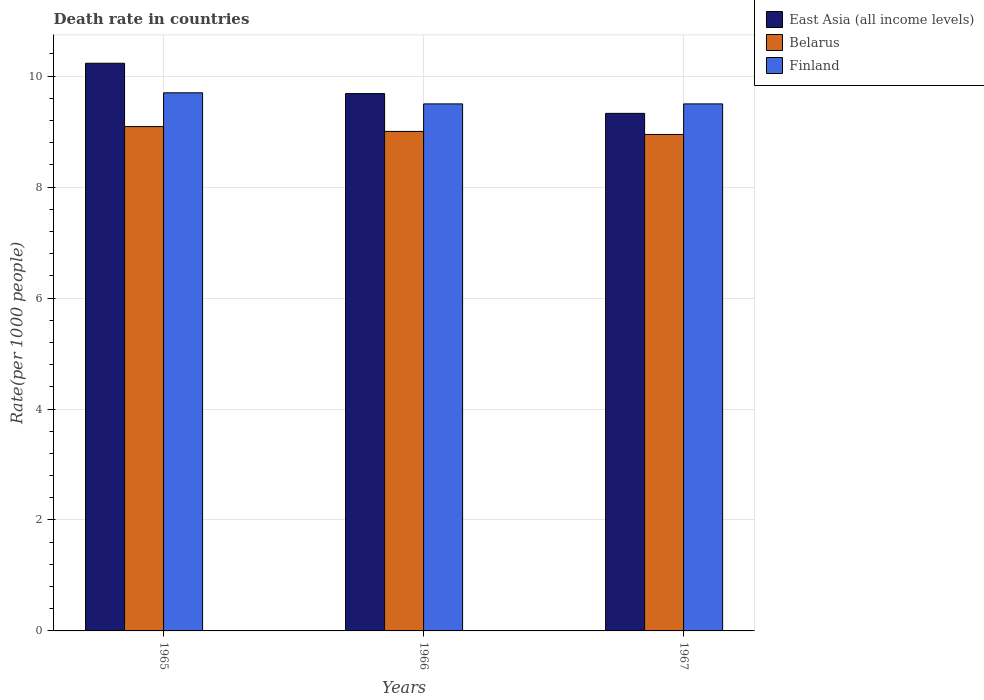How many different coloured bars are there?
Your answer should be compact. 3. How many groups of bars are there?
Keep it short and to the point. 3. Are the number of bars per tick equal to the number of legend labels?
Offer a very short reply. Yes. Are the number of bars on each tick of the X-axis equal?
Ensure brevity in your answer.  Yes. How many bars are there on the 2nd tick from the right?
Keep it short and to the point. 3. What is the label of the 3rd group of bars from the left?
Provide a short and direct response. 1967. What is the death rate in East Asia (all income levels) in 1966?
Your response must be concise. 9.69. Across all years, what is the maximum death rate in Belarus?
Keep it short and to the point. 9.09. Across all years, what is the minimum death rate in Belarus?
Ensure brevity in your answer.  8.95. In which year was the death rate in Belarus maximum?
Keep it short and to the point. 1965. In which year was the death rate in Belarus minimum?
Your answer should be compact. 1967. What is the total death rate in Belarus in the graph?
Offer a terse response. 27.04. What is the difference between the death rate in East Asia (all income levels) in 1966 and that in 1967?
Make the answer very short. 0.36. What is the difference between the death rate in Belarus in 1965 and the death rate in Finland in 1967?
Give a very brief answer. -0.41. What is the average death rate in Belarus per year?
Your response must be concise. 9.01. In the year 1965, what is the difference between the death rate in Belarus and death rate in East Asia (all income levels)?
Offer a terse response. -1.14. In how many years, is the death rate in East Asia (all income levels) greater than 2.8?
Your answer should be very brief. 3. What is the ratio of the death rate in East Asia (all income levels) in 1965 to that in 1967?
Provide a succinct answer. 1.1. Is the difference between the death rate in Belarus in 1965 and 1967 greater than the difference between the death rate in East Asia (all income levels) in 1965 and 1967?
Give a very brief answer. No. What is the difference between the highest and the second highest death rate in Finland?
Provide a succinct answer. 0.2. What is the difference between the highest and the lowest death rate in Finland?
Your response must be concise. 0.2. What does the 3rd bar from the right in 1966 represents?
Ensure brevity in your answer.  East Asia (all income levels). Is it the case that in every year, the sum of the death rate in Belarus and death rate in East Asia (all income levels) is greater than the death rate in Finland?
Offer a very short reply. Yes. How many bars are there?
Provide a succinct answer. 9. Does the graph contain any zero values?
Ensure brevity in your answer.  No. Where does the legend appear in the graph?
Ensure brevity in your answer.  Top right. How are the legend labels stacked?
Your answer should be compact. Vertical. What is the title of the graph?
Offer a very short reply. Death rate in countries. Does "South Africa" appear as one of the legend labels in the graph?
Give a very brief answer. No. What is the label or title of the Y-axis?
Ensure brevity in your answer.  Rate(per 1000 people). What is the Rate(per 1000 people) in East Asia (all income levels) in 1965?
Ensure brevity in your answer.  10.23. What is the Rate(per 1000 people) in Belarus in 1965?
Ensure brevity in your answer.  9.09. What is the Rate(per 1000 people) in East Asia (all income levels) in 1966?
Offer a terse response. 9.69. What is the Rate(per 1000 people) in Belarus in 1966?
Offer a terse response. 9. What is the Rate(per 1000 people) of East Asia (all income levels) in 1967?
Your response must be concise. 9.33. What is the Rate(per 1000 people) in Belarus in 1967?
Keep it short and to the point. 8.95. What is the Rate(per 1000 people) in Finland in 1967?
Provide a short and direct response. 9.5. Across all years, what is the maximum Rate(per 1000 people) in East Asia (all income levels)?
Provide a succinct answer. 10.23. Across all years, what is the maximum Rate(per 1000 people) in Belarus?
Give a very brief answer. 9.09. Across all years, what is the minimum Rate(per 1000 people) in East Asia (all income levels)?
Give a very brief answer. 9.33. Across all years, what is the minimum Rate(per 1000 people) of Belarus?
Your answer should be compact. 8.95. Across all years, what is the minimum Rate(per 1000 people) of Finland?
Provide a succinct answer. 9.5. What is the total Rate(per 1000 people) in East Asia (all income levels) in the graph?
Your answer should be compact. 29.25. What is the total Rate(per 1000 people) of Belarus in the graph?
Provide a short and direct response. 27.04. What is the total Rate(per 1000 people) of Finland in the graph?
Provide a succinct answer. 28.7. What is the difference between the Rate(per 1000 people) in East Asia (all income levels) in 1965 and that in 1966?
Ensure brevity in your answer.  0.55. What is the difference between the Rate(per 1000 people) of Belarus in 1965 and that in 1966?
Provide a succinct answer. 0.09. What is the difference between the Rate(per 1000 people) of East Asia (all income levels) in 1965 and that in 1967?
Provide a succinct answer. 0.9. What is the difference between the Rate(per 1000 people) in Belarus in 1965 and that in 1967?
Your answer should be compact. 0.14. What is the difference between the Rate(per 1000 people) in East Asia (all income levels) in 1966 and that in 1967?
Your answer should be very brief. 0.36. What is the difference between the Rate(per 1000 people) of Belarus in 1966 and that in 1967?
Ensure brevity in your answer.  0.06. What is the difference between the Rate(per 1000 people) in Finland in 1966 and that in 1967?
Offer a very short reply. 0. What is the difference between the Rate(per 1000 people) of East Asia (all income levels) in 1965 and the Rate(per 1000 people) of Belarus in 1966?
Your answer should be very brief. 1.23. What is the difference between the Rate(per 1000 people) of East Asia (all income levels) in 1965 and the Rate(per 1000 people) of Finland in 1966?
Your response must be concise. 0.73. What is the difference between the Rate(per 1000 people) in Belarus in 1965 and the Rate(per 1000 people) in Finland in 1966?
Provide a succinct answer. -0.41. What is the difference between the Rate(per 1000 people) of East Asia (all income levels) in 1965 and the Rate(per 1000 people) of Belarus in 1967?
Offer a terse response. 1.28. What is the difference between the Rate(per 1000 people) in East Asia (all income levels) in 1965 and the Rate(per 1000 people) in Finland in 1967?
Your answer should be very brief. 0.73. What is the difference between the Rate(per 1000 people) in Belarus in 1965 and the Rate(per 1000 people) in Finland in 1967?
Offer a very short reply. -0.41. What is the difference between the Rate(per 1000 people) of East Asia (all income levels) in 1966 and the Rate(per 1000 people) of Belarus in 1967?
Your answer should be compact. 0.74. What is the difference between the Rate(per 1000 people) in East Asia (all income levels) in 1966 and the Rate(per 1000 people) in Finland in 1967?
Give a very brief answer. 0.19. What is the difference between the Rate(per 1000 people) of Belarus in 1966 and the Rate(per 1000 people) of Finland in 1967?
Provide a succinct answer. -0.5. What is the average Rate(per 1000 people) of East Asia (all income levels) per year?
Provide a short and direct response. 9.75. What is the average Rate(per 1000 people) in Belarus per year?
Make the answer very short. 9.01. What is the average Rate(per 1000 people) in Finland per year?
Offer a very short reply. 9.57. In the year 1965, what is the difference between the Rate(per 1000 people) in East Asia (all income levels) and Rate(per 1000 people) in Belarus?
Give a very brief answer. 1.14. In the year 1965, what is the difference between the Rate(per 1000 people) of East Asia (all income levels) and Rate(per 1000 people) of Finland?
Offer a very short reply. 0.53. In the year 1965, what is the difference between the Rate(per 1000 people) in Belarus and Rate(per 1000 people) in Finland?
Make the answer very short. -0.61. In the year 1966, what is the difference between the Rate(per 1000 people) of East Asia (all income levels) and Rate(per 1000 people) of Belarus?
Your answer should be very brief. 0.68. In the year 1966, what is the difference between the Rate(per 1000 people) of East Asia (all income levels) and Rate(per 1000 people) of Finland?
Ensure brevity in your answer.  0.19. In the year 1966, what is the difference between the Rate(per 1000 people) in Belarus and Rate(per 1000 people) in Finland?
Provide a succinct answer. -0.5. In the year 1967, what is the difference between the Rate(per 1000 people) of East Asia (all income levels) and Rate(per 1000 people) of Belarus?
Give a very brief answer. 0.38. In the year 1967, what is the difference between the Rate(per 1000 people) of East Asia (all income levels) and Rate(per 1000 people) of Finland?
Your answer should be compact. -0.17. In the year 1967, what is the difference between the Rate(per 1000 people) of Belarus and Rate(per 1000 people) of Finland?
Provide a short and direct response. -0.55. What is the ratio of the Rate(per 1000 people) in East Asia (all income levels) in 1965 to that in 1966?
Your response must be concise. 1.06. What is the ratio of the Rate(per 1000 people) in Belarus in 1965 to that in 1966?
Your answer should be very brief. 1.01. What is the ratio of the Rate(per 1000 people) of Finland in 1965 to that in 1966?
Give a very brief answer. 1.02. What is the ratio of the Rate(per 1000 people) of East Asia (all income levels) in 1965 to that in 1967?
Offer a very short reply. 1.1. What is the ratio of the Rate(per 1000 people) of Belarus in 1965 to that in 1967?
Your answer should be very brief. 1.02. What is the ratio of the Rate(per 1000 people) of Finland in 1965 to that in 1967?
Your answer should be compact. 1.02. What is the ratio of the Rate(per 1000 people) of East Asia (all income levels) in 1966 to that in 1967?
Your answer should be compact. 1.04. What is the ratio of the Rate(per 1000 people) in Belarus in 1966 to that in 1967?
Give a very brief answer. 1.01. What is the ratio of the Rate(per 1000 people) in Finland in 1966 to that in 1967?
Give a very brief answer. 1. What is the difference between the highest and the second highest Rate(per 1000 people) in East Asia (all income levels)?
Your response must be concise. 0.55. What is the difference between the highest and the second highest Rate(per 1000 people) of Belarus?
Your answer should be compact. 0.09. What is the difference between the highest and the lowest Rate(per 1000 people) of East Asia (all income levels)?
Make the answer very short. 0.9. What is the difference between the highest and the lowest Rate(per 1000 people) in Belarus?
Your answer should be very brief. 0.14. 